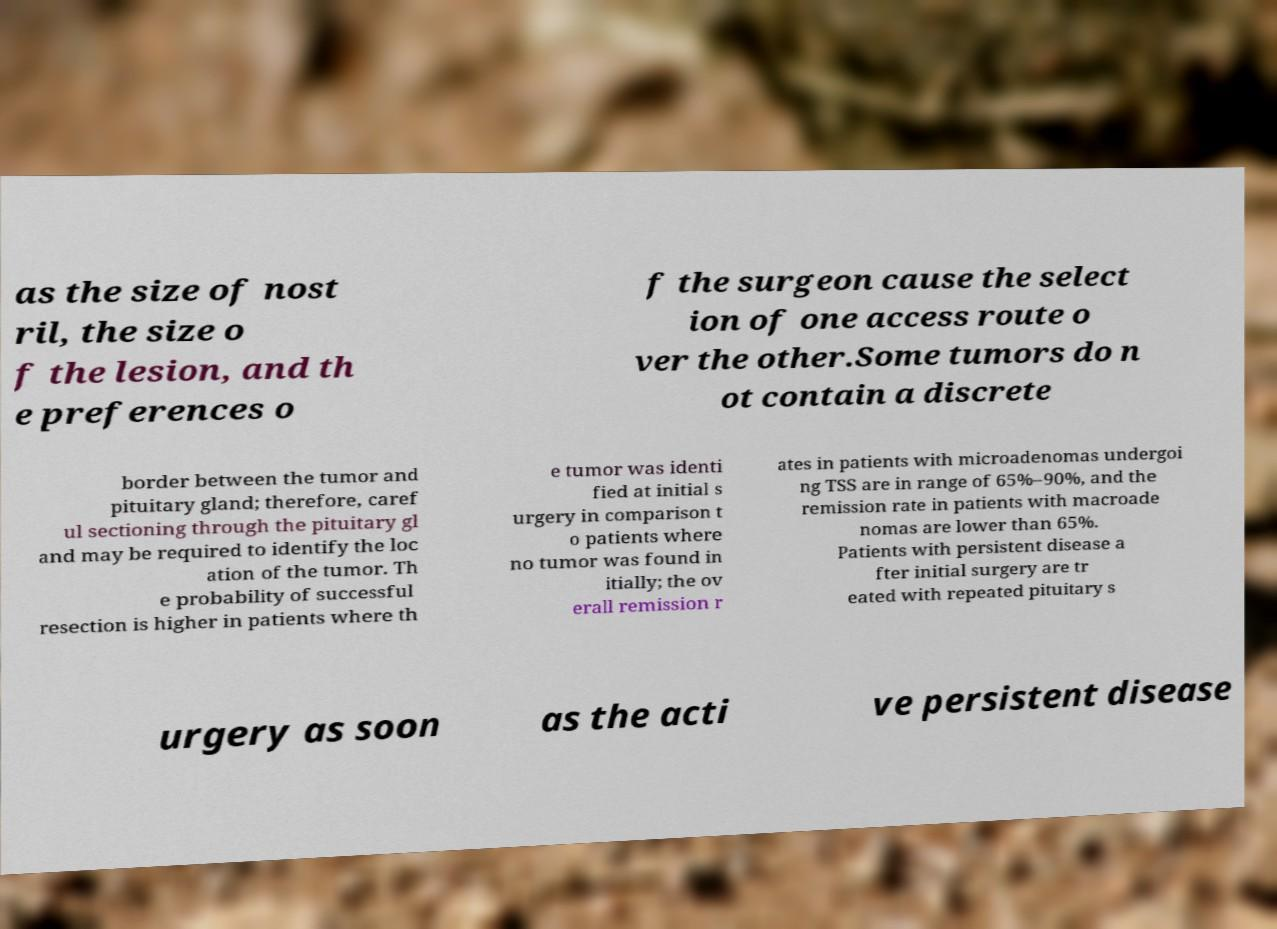I need the written content from this picture converted into text. Can you do that? as the size of nost ril, the size o f the lesion, and th e preferences o f the surgeon cause the select ion of one access route o ver the other.Some tumors do n ot contain a discrete border between the tumor and pituitary gland; therefore, caref ul sectioning through the pituitary gl and may be required to identify the loc ation of the tumor. Th e probability of successful resection is higher in patients where th e tumor was identi fied at initial s urgery in comparison t o patients where no tumor was found in itially; the ov erall remission r ates in patients with microadenomas undergoi ng TSS are in range of 65%–90%, and the remission rate in patients with macroade nomas are lower than 65%. Patients with persistent disease a fter initial surgery are tr eated with repeated pituitary s urgery as soon as the acti ve persistent disease 